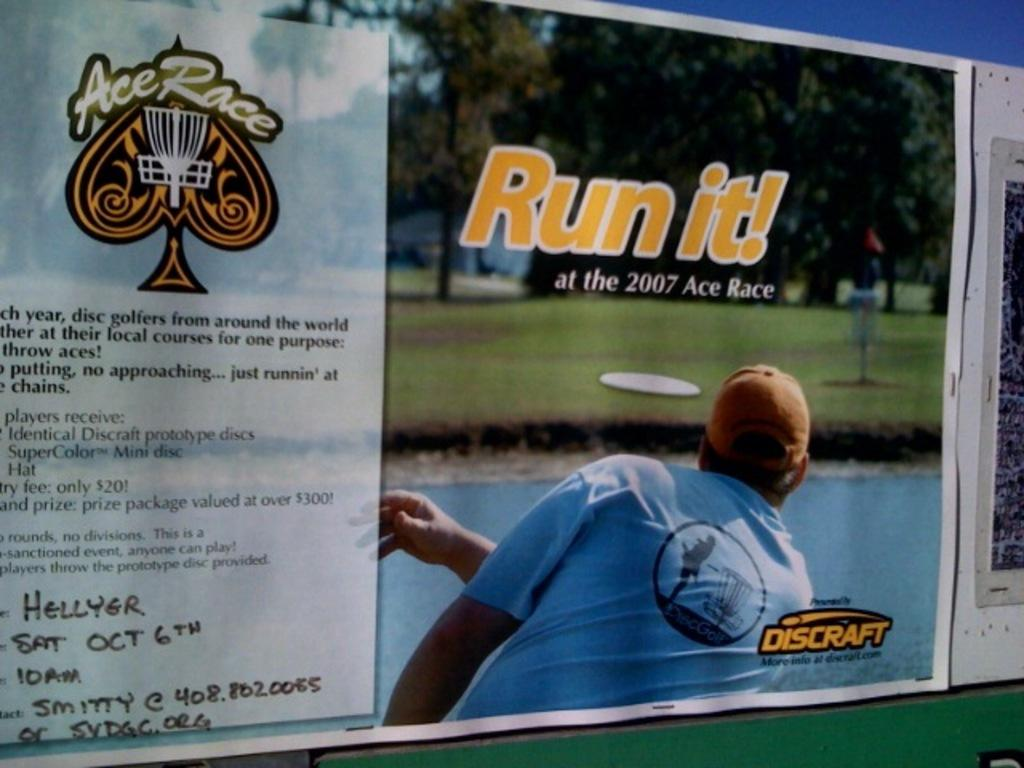What is present in the image? There is a poster in the image. What is depicted on the poster? The poster contains a person. Are there any words or letters on the poster? Yes, the poster contains text. Can you see a goat grazing in the background of the poster? There is no goat present in the image or on the poster. Is there a volcano erupting in the background of the poster? There is no volcano present in the image or on the poster. 